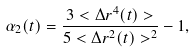Convert formula to latex. <formula><loc_0><loc_0><loc_500><loc_500>\alpha _ { 2 } ( t ) = \frac { 3 < \Delta r ^ { 4 } ( t ) > } { 5 < \Delta r ^ { 2 } ( t ) > ^ { 2 } } - 1 ,</formula> 